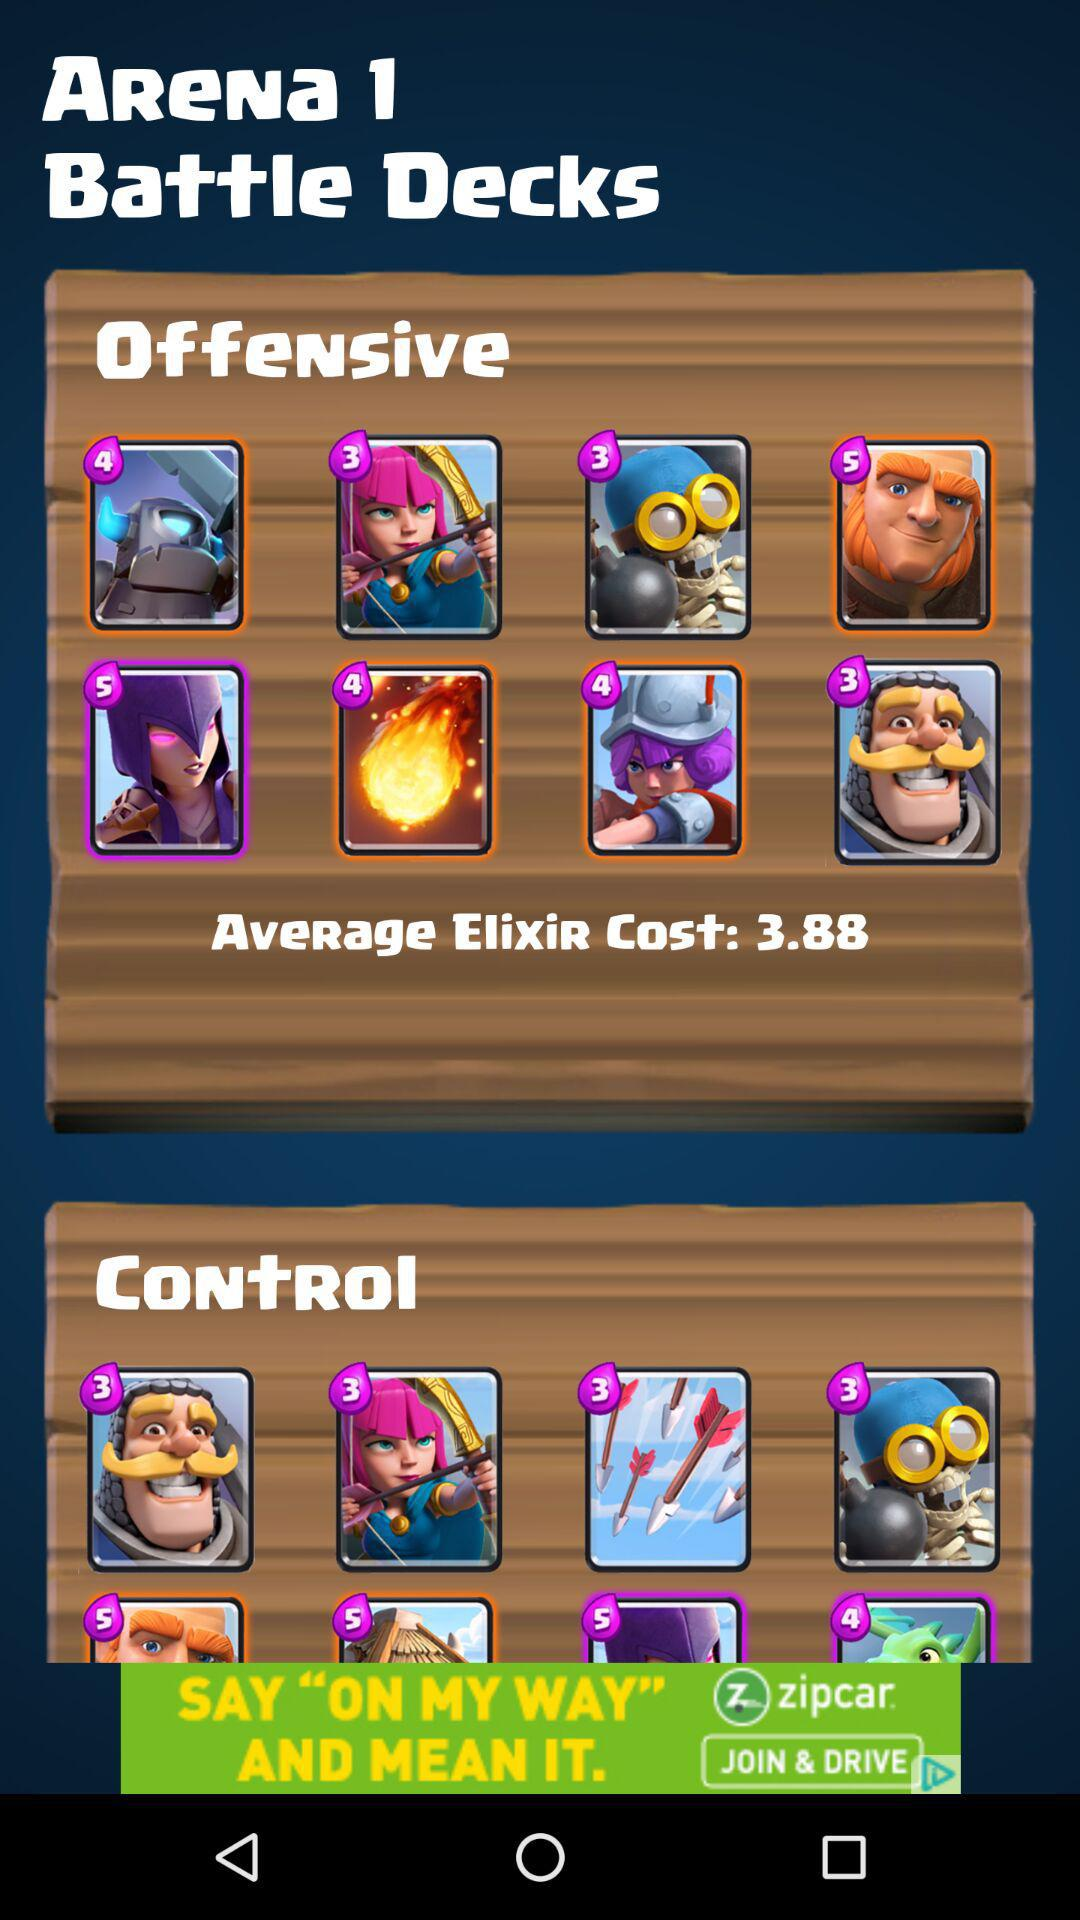What is the average elixir cost? The average elixir cost is 3.88. 